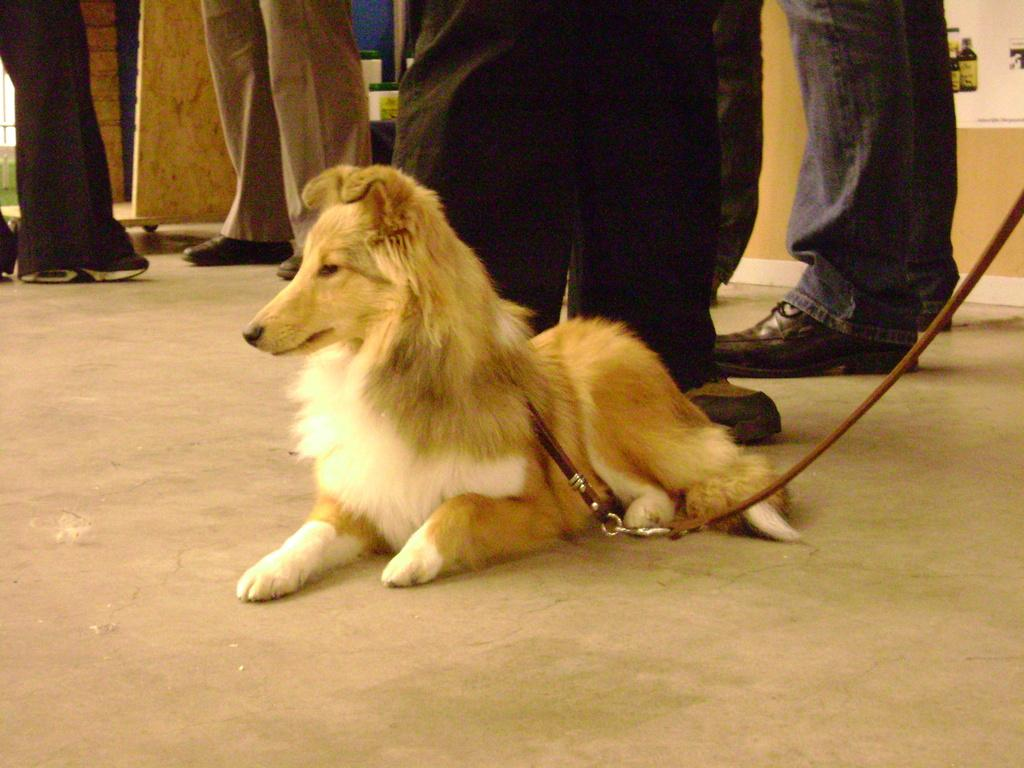What animal is sitting on the floor in the image? There is a dog sitting on the floor in the image. What type of clothing accessory is visible in the image? There is a belt visible in the image. What part of a person can be seen in the image? Human legs with footwear are present in the image. What type of structure is in the background of the image? There is a wall in the image. What type of decoration is present in the image? There is a poster in the image. What type of objects are present in the image? There are containers in the image. Can you see a squirrel turning a print in the image? There is no squirrel or print present in the image. 